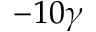<formula> <loc_0><loc_0><loc_500><loc_500>- 1 0 \gamma</formula> 